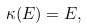<formula> <loc_0><loc_0><loc_500><loc_500>\kappa ( E ) = E ,</formula> 